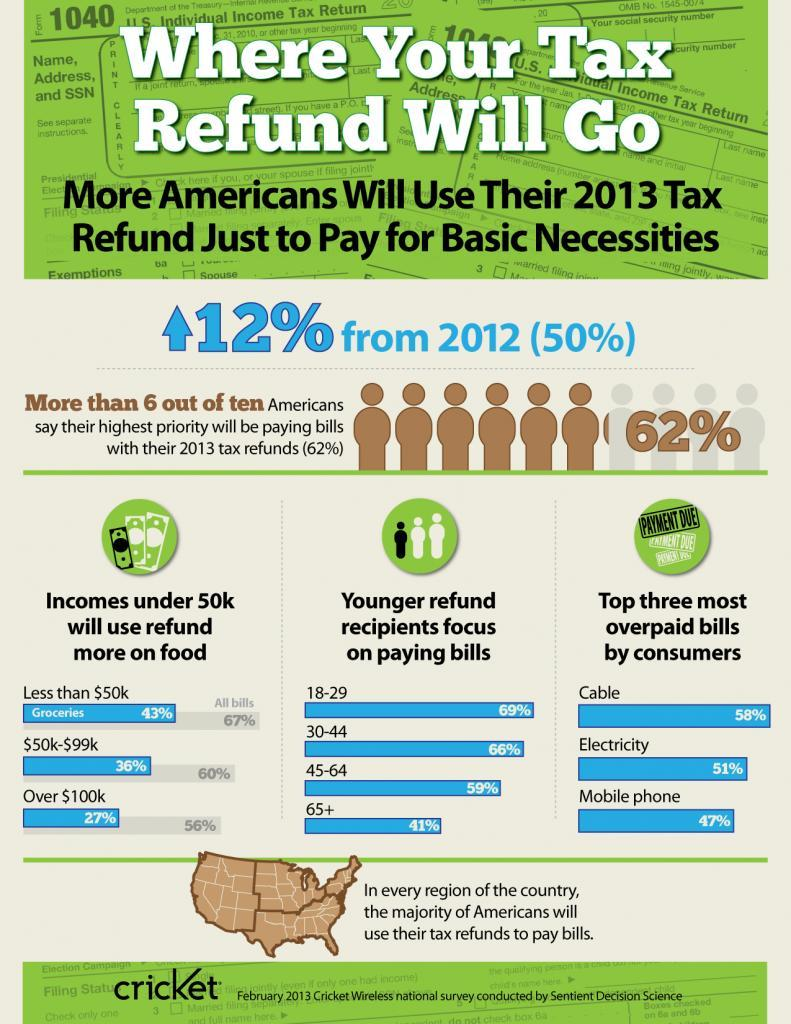what % of senior citizens focus on paying bills
Answer the question with a short phrase. 41% What are the top three most overpaid bills by consumers Cable, Electricity, Mobile Phone What % of refund will be used on food by people over $100k income 27% 